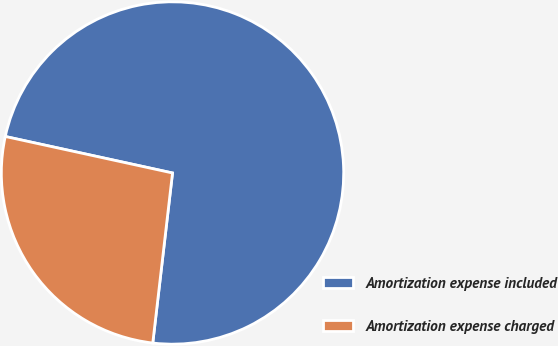Convert chart. <chart><loc_0><loc_0><loc_500><loc_500><pie_chart><fcel>Amortization expense included<fcel>Amortization expense charged<nl><fcel>73.42%<fcel>26.58%<nl></chart> 